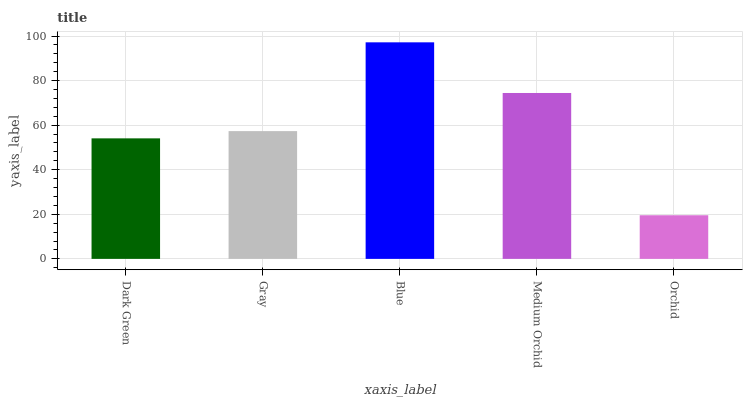Is Orchid the minimum?
Answer yes or no. Yes. Is Blue the maximum?
Answer yes or no. Yes. Is Gray the minimum?
Answer yes or no. No. Is Gray the maximum?
Answer yes or no. No. Is Gray greater than Dark Green?
Answer yes or no. Yes. Is Dark Green less than Gray?
Answer yes or no. Yes. Is Dark Green greater than Gray?
Answer yes or no. No. Is Gray less than Dark Green?
Answer yes or no. No. Is Gray the high median?
Answer yes or no. Yes. Is Gray the low median?
Answer yes or no. Yes. Is Medium Orchid the high median?
Answer yes or no. No. Is Medium Orchid the low median?
Answer yes or no. No. 